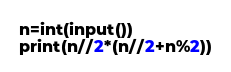Convert code to text. <code><loc_0><loc_0><loc_500><loc_500><_Python_>n=int(input())
print(n//2*(n//2+n%2))</code> 